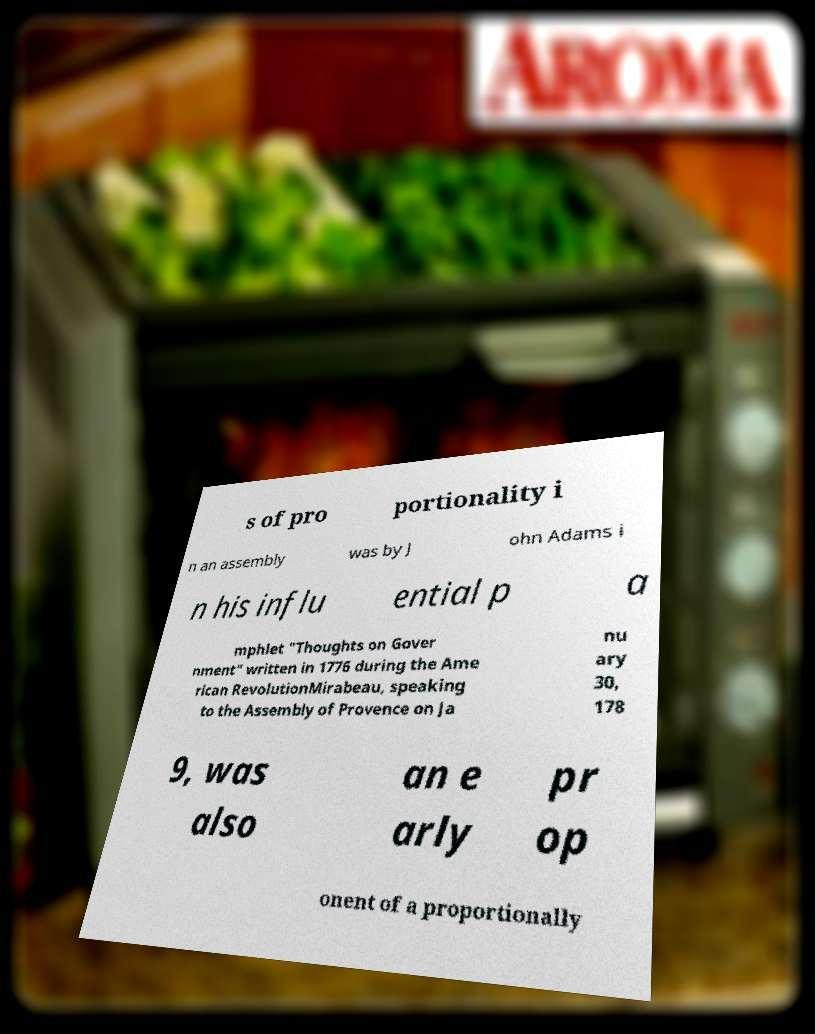Can you read and provide the text displayed in the image?This photo seems to have some interesting text. Can you extract and type it out for me? s of pro portionality i n an assembly was by J ohn Adams i n his influ ential p a mphlet "Thoughts on Gover nment" written in 1776 during the Ame rican RevolutionMirabeau, speaking to the Assembly of Provence on Ja nu ary 30, 178 9, was also an e arly pr op onent of a proportionally 